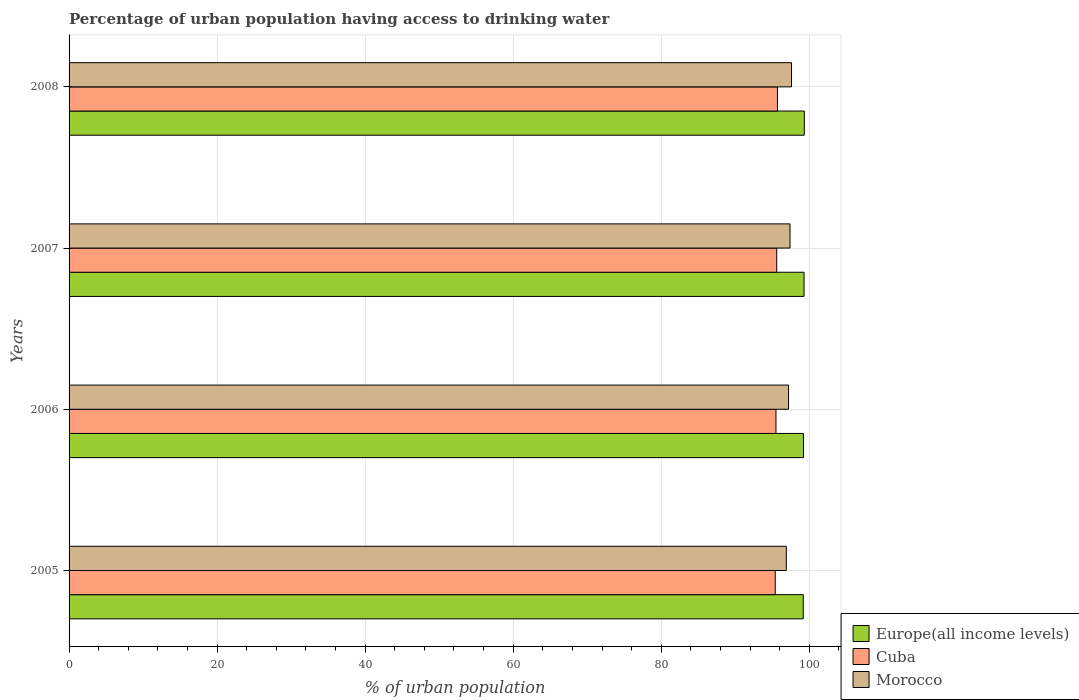How many bars are there on the 4th tick from the top?
Your answer should be compact. 3. How many bars are there on the 1st tick from the bottom?
Provide a short and direct response. 3. In how many cases, is the number of bars for a given year not equal to the number of legend labels?
Offer a very short reply. 0. What is the percentage of urban population having access to drinking water in Europe(all income levels) in 2005?
Your answer should be very brief. 99.19. Across all years, what is the maximum percentage of urban population having access to drinking water in Cuba?
Give a very brief answer. 95.7. Across all years, what is the minimum percentage of urban population having access to drinking water in Morocco?
Offer a very short reply. 96.9. In which year was the percentage of urban population having access to drinking water in Cuba maximum?
Provide a short and direct response. 2008. In which year was the percentage of urban population having access to drinking water in Cuba minimum?
Provide a succinct answer. 2005. What is the total percentage of urban population having access to drinking water in Morocco in the graph?
Ensure brevity in your answer.  389.1. What is the difference between the percentage of urban population having access to drinking water in Europe(all income levels) in 2007 and that in 2008?
Offer a very short reply. -0.03. What is the difference between the percentage of urban population having access to drinking water in Morocco in 2008 and the percentage of urban population having access to drinking water in Europe(all income levels) in 2007?
Offer a terse response. -1.69. What is the average percentage of urban population having access to drinking water in Cuba per year?
Offer a very short reply. 95.55. In the year 2005, what is the difference between the percentage of urban population having access to drinking water in Cuba and percentage of urban population having access to drinking water in Europe(all income levels)?
Make the answer very short. -3.79. What is the ratio of the percentage of urban population having access to drinking water in Cuba in 2005 to that in 2006?
Your response must be concise. 1. Is the percentage of urban population having access to drinking water in Morocco in 2005 less than that in 2008?
Provide a short and direct response. Yes. What is the difference between the highest and the second highest percentage of urban population having access to drinking water in Cuba?
Your response must be concise. 0.1. What is the difference between the highest and the lowest percentage of urban population having access to drinking water in Morocco?
Your answer should be very brief. 0.7. Is the sum of the percentage of urban population having access to drinking water in Morocco in 2007 and 2008 greater than the maximum percentage of urban population having access to drinking water in Europe(all income levels) across all years?
Offer a very short reply. Yes. What does the 2nd bar from the top in 2007 represents?
Your answer should be very brief. Cuba. What does the 1st bar from the bottom in 2005 represents?
Your answer should be very brief. Europe(all income levels). Is it the case that in every year, the sum of the percentage of urban population having access to drinking water in Cuba and percentage of urban population having access to drinking water in Morocco is greater than the percentage of urban population having access to drinking water in Europe(all income levels)?
Keep it short and to the point. Yes. Are all the bars in the graph horizontal?
Provide a short and direct response. Yes. Does the graph contain any zero values?
Offer a very short reply. No. Does the graph contain grids?
Offer a terse response. Yes. Where does the legend appear in the graph?
Your response must be concise. Bottom right. How many legend labels are there?
Ensure brevity in your answer.  3. What is the title of the graph?
Provide a succinct answer. Percentage of urban population having access to drinking water. Does "Monaco" appear as one of the legend labels in the graph?
Offer a very short reply. No. What is the label or title of the X-axis?
Offer a terse response. % of urban population. What is the label or title of the Y-axis?
Provide a succinct answer. Years. What is the % of urban population of Europe(all income levels) in 2005?
Ensure brevity in your answer.  99.19. What is the % of urban population of Cuba in 2005?
Offer a terse response. 95.4. What is the % of urban population in Morocco in 2005?
Your response must be concise. 96.9. What is the % of urban population in Europe(all income levels) in 2006?
Make the answer very short. 99.21. What is the % of urban population in Cuba in 2006?
Make the answer very short. 95.5. What is the % of urban population of Morocco in 2006?
Your answer should be very brief. 97.2. What is the % of urban population of Europe(all income levels) in 2007?
Provide a short and direct response. 99.29. What is the % of urban population in Cuba in 2007?
Your answer should be very brief. 95.6. What is the % of urban population of Morocco in 2007?
Offer a very short reply. 97.4. What is the % of urban population of Europe(all income levels) in 2008?
Provide a short and direct response. 99.33. What is the % of urban population in Cuba in 2008?
Your answer should be very brief. 95.7. What is the % of urban population in Morocco in 2008?
Keep it short and to the point. 97.6. Across all years, what is the maximum % of urban population of Europe(all income levels)?
Offer a terse response. 99.33. Across all years, what is the maximum % of urban population of Cuba?
Your answer should be very brief. 95.7. Across all years, what is the maximum % of urban population of Morocco?
Make the answer very short. 97.6. Across all years, what is the minimum % of urban population in Europe(all income levels)?
Keep it short and to the point. 99.19. Across all years, what is the minimum % of urban population in Cuba?
Provide a short and direct response. 95.4. Across all years, what is the minimum % of urban population of Morocco?
Provide a short and direct response. 96.9. What is the total % of urban population of Europe(all income levels) in the graph?
Your response must be concise. 397.02. What is the total % of urban population in Cuba in the graph?
Your response must be concise. 382.2. What is the total % of urban population of Morocco in the graph?
Offer a very short reply. 389.1. What is the difference between the % of urban population in Europe(all income levels) in 2005 and that in 2006?
Keep it short and to the point. -0.03. What is the difference between the % of urban population of Morocco in 2005 and that in 2006?
Make the answer very short. -0.3. What is the difference between the % of urban population in Europe(all income levels) in 2005 and that in 2007?
Provide a succinct answer. -0.11. What is the difference between the % of urban population of Europe(all income levels) in 2005 and that in 2008?
Give a very brief answer. -0.14. What is the difference between the % of urban population in Cuba in 2005 and that in 2008?
Provide a succinct answer. -0.3. What is the difference between the % of urban population of Europe(all income levels) in 2006 and that in 2007?
Keep it short and to the point. -0.08. What is the difference between the % of urban population of Cuba in 2006 and that in 2007?
Your response must be concise. -0.1. What is the difference between the % of urban population of Morocco in 2006 and that in 2007?
Give a very brief answer. -0.2. What is the difference between the % of urban population in Europe(all income levels) in 2006 and that in 2008?
Provide a succinct answer. -0.11. What is the difference between the % of urban population of Cuba in 2006 and that in 2008?
Ensure brevity in your answer.  -0.2. What is the difference between the % of urban population in Europe(all income levels) in 2007 and that in 2008?
Offer a very short reply. -0.03. What is the difference between the % of urban population of Europe(all income levels) in 2005 and the % of urban population of Cuba in 2006?
Make the answer very short. 3.69. What is the difference between the % of urban population in Europe(all income levels) in 2005 and the % of urban population in Morocco in 2006?
Make the answer very short. 1.99. What is the difference between the % of urban population of Cuba in 2005 and the % of urban population of Morocco in 2006?
Keep it short and to the point. -1.8. What is the difference between the % of urban population in Europe(all income levels) in 2005 and the % of urban population in Cuba in 2007?
Your answer should be compact. 3.59. What is the difference between the % of urban population of Europe(all income levels) in 2005 and the % of urban population of Morocco in 2007?
Your response must be concise. 1.79. What is the difference between the % of urban population of Cuba in 2005 and the % of urban population of Morocco in 2007?
Offer a very short reply. -2. What is the difference between the % of urban population of Europe(all income levels) in 2005 and the % of urban population of Cuba in 2008?
Your answer should be very brief. 3.49. What is the difference between the % of urban population of Europe(all income levels) in 2005 and the % of urban population of Morocco in 2008?
Offer a very short reply. 1.59. What is the difference between the % of urban population in Europe(all income levels) in 2006 and the % of urban population in Cuba in 2007?
Make the answer very short. 3.61. What is the difference between the % of urban population of Europe(all income levels) in 2006 and the % of urban population of Morocco in 2007?
Provide a succinct answer. 1.81. What is the difference between the % of urban population in Europe(all income levels) in 2006 and the % of urban population in Cuba in 2008?
Keep it short and to the point. 3.51. What is the difference between the % of urban population of Europe(all income levels) in 2006 and the % of urban population of Morocco in 2008?
Your answer should be very brief. 1.61. What is the difference between the % of urban population in Cuba in 2006 and the % of urban population in Morocco in 2008?
Make the answer very short. -2.1. What is the difference between the % of urban population of Europe(all income levels) in 2007 and the % of urban population of Cuba in 2008?
Offer a terse response. 3.59. What is the difference between the % of urban population in Europe(all income levels) in 2007 and the % of urban population in Morocco in 2008?
Your answer should be compact. 1.69. What is the difference between the % of urban population of Cuba in 2007 and the % of urban population of Morocco in 2008?
Make the answer very short. -2. What is the average % of urban population of Europe(all income levels) per year?
Ensure brevity in your answer.  99.25. What is the average % of urban population of Cuba per year?
Keep it short and to the point. 95.55. What is the average % of urban population in Morocco per year?
Give a very brief answer. 97.28. In the year 2005, what is the difference between the % of urban population in Europe(all income levels) and % of urban population in Cuba?
Offer a terse response. 3.79. In the year 2005, what is the difference between the % of urban population in Europe(all income levels) and % of urban population in Morocco?
Provide a succinct answer. 2.29. In the year 2006, what is the difference between the % of urban population in Europe(all income levels) and % of urban population in Cuba?
Offer a terse response. 3.71. In the year 2006, what is the difference between the % of urban population of Europe(all income levels) and % of urban population of Morocco?
Your answer should be very brief. 2.01. In the year 2006, what is the difference between the % of urban population of Cuba and % of urban population of Morocco?
Your answer should be compact. -1.7. In the year 2007, what is the difference between the % of urban population of Europe(all income levels) and % of urban population of Cuba?
Your answer should be compact. 3.69. In the year 2007, what is the difference between the % of urban population in Europe(all income levels) and % of urban population in Morocco?
Keep it short and to the point. 1.89. In the year 2007, what is the difference between the % of urban population in Cuba and % of urban population in Morocco?
Your answer should be very brief. -1.8. In the year 2008, what is the difference between the % of urban population of Europe(all income levels) and % of urban population of Cuba?
Your response must be concise. 3.63. In the year 2008, what is the difference between the % of urban population in Europe(all income levels) and % of urban population in Morocco?
Offer a terse response. 1.73. What is the ratio of the % of urban population in Cuba in 2005 to that in 2006?
Offer a terse response. 1. What is the ratio of the % of urban population of Morocco in 2005 to that in 2006?
Keep it short and to the point. 1. What is the ratio of the % of urban population of Europe(all income levels) in 2005 to that in 2007?
Your response must be concise. 1. What is the ratio of the % of urban population in Morocco in 2005 to that in 2007?
Your answer should be compact. 0.99. What is the ratio of the % of urban population of Cuba in 2005 to that in 2008?
Ensure brevity in your answer.  1. What is the ratio of the % of urban population in Morocco in 2006 to that in 2007?
Your response must be concise. 1. What is the ratio of the % of urban population of Europe(all income levels) in 2006 to that in 2008?
Make the answer very short. 1. What is the ratio of the % of urban population of Morocco in 2006 to that in 2008?
Make the answer very short. 1. What is the ratio of the % of urban population in Europe(all income levels) in 2007 to that in 2008?
Your response must be concise. 1. What is the ratio of the % of urban population of Cuba in 2007 to that in 2008?
Offer a very short reply. 1. What is the difference between the highest and the second highest % of urban population of Europe(all income levels)?
Offer a very short reply. 0.03. What is the difference between the highest and the lowest % of urban population in Europe(all income levels)?
Give a very brief answer. 0.14. What is the difference between the highest and the lowest % of urban population of Cuba?
Your answer should be compact. 0.3. 